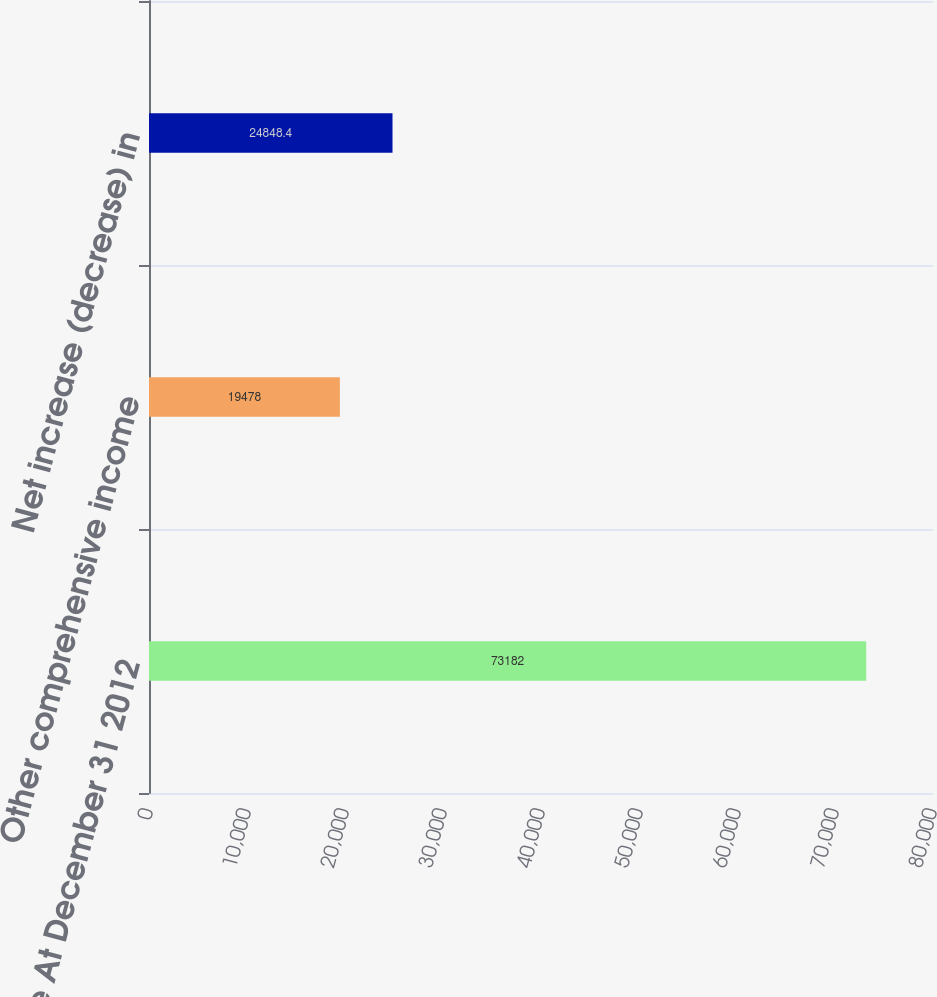Convert chart to OTSL. <chart><loc_0><loc_0><loc_500><loc_500><bar_chart><fcel>Balance At December 31 2012<fcel>Other comprehensive income<fcel>Net increase (decrease) in<nl><fcel>73182<fcel>19478<fcel>24848.4<nl></chart> 